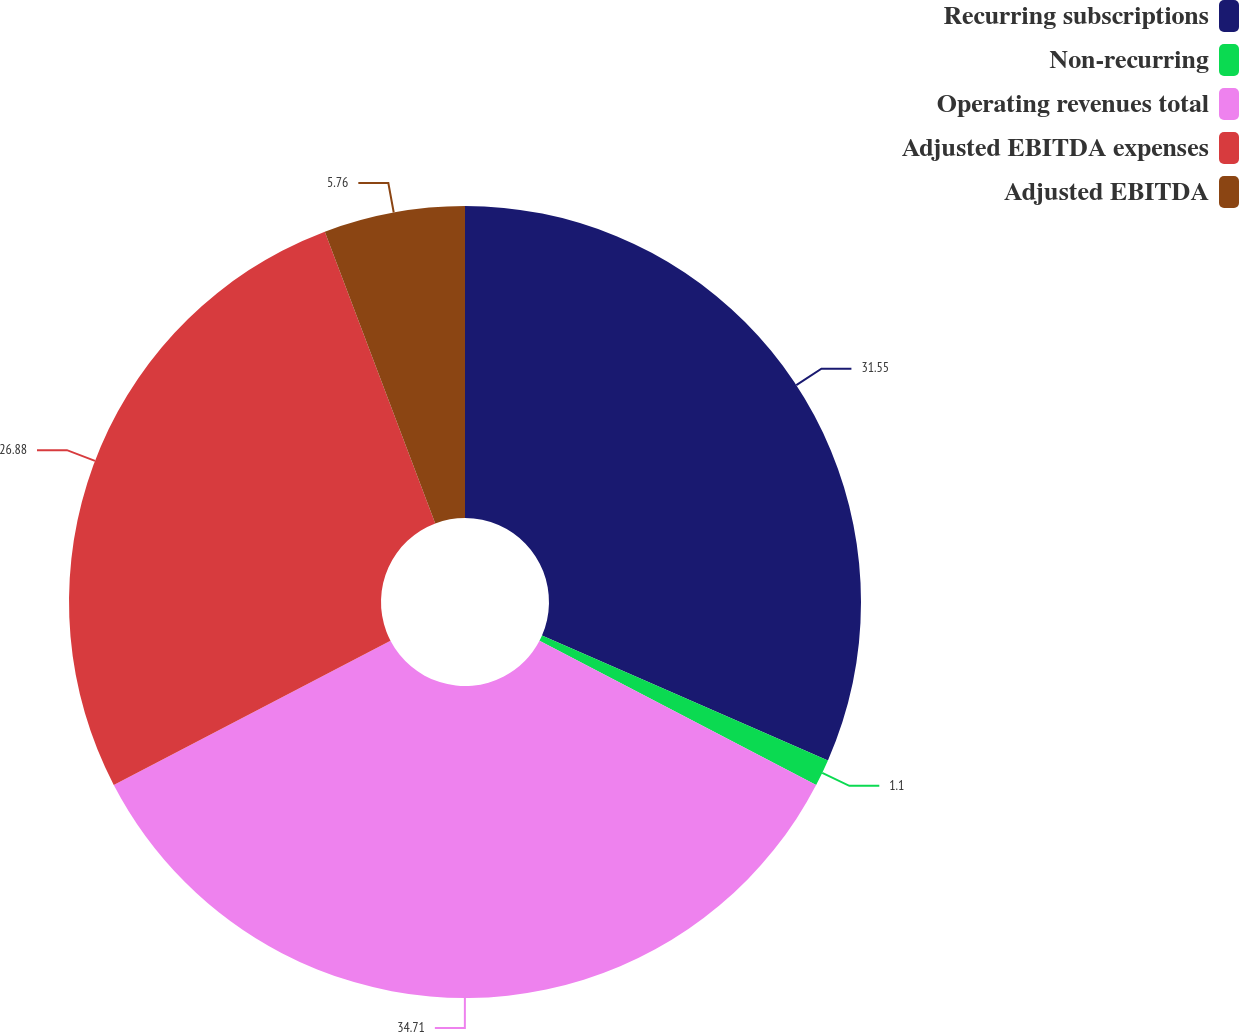Convert chart to OTSL. <chart><loc_0><loc_0><loc_500><loc_500><pie_chart><fcel>Recurring subscriptions<fcel>Non-recurring<fcel>Operating revenues total<fcel>Adjusted EBITDA expenses<fcel>Adjusted EBITDA<nl><fcel>31.55%<fcel>1.1%<fcel>34.71%<fcel>26.88%<fcel>5.76%<nl></chart> 